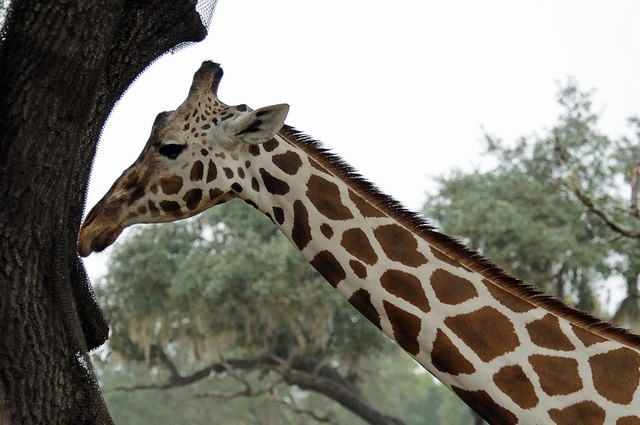Describe the objects in this image and their specific colors. I can see a giraffe in gray, maroon, black, and darkgray tones in this image. 